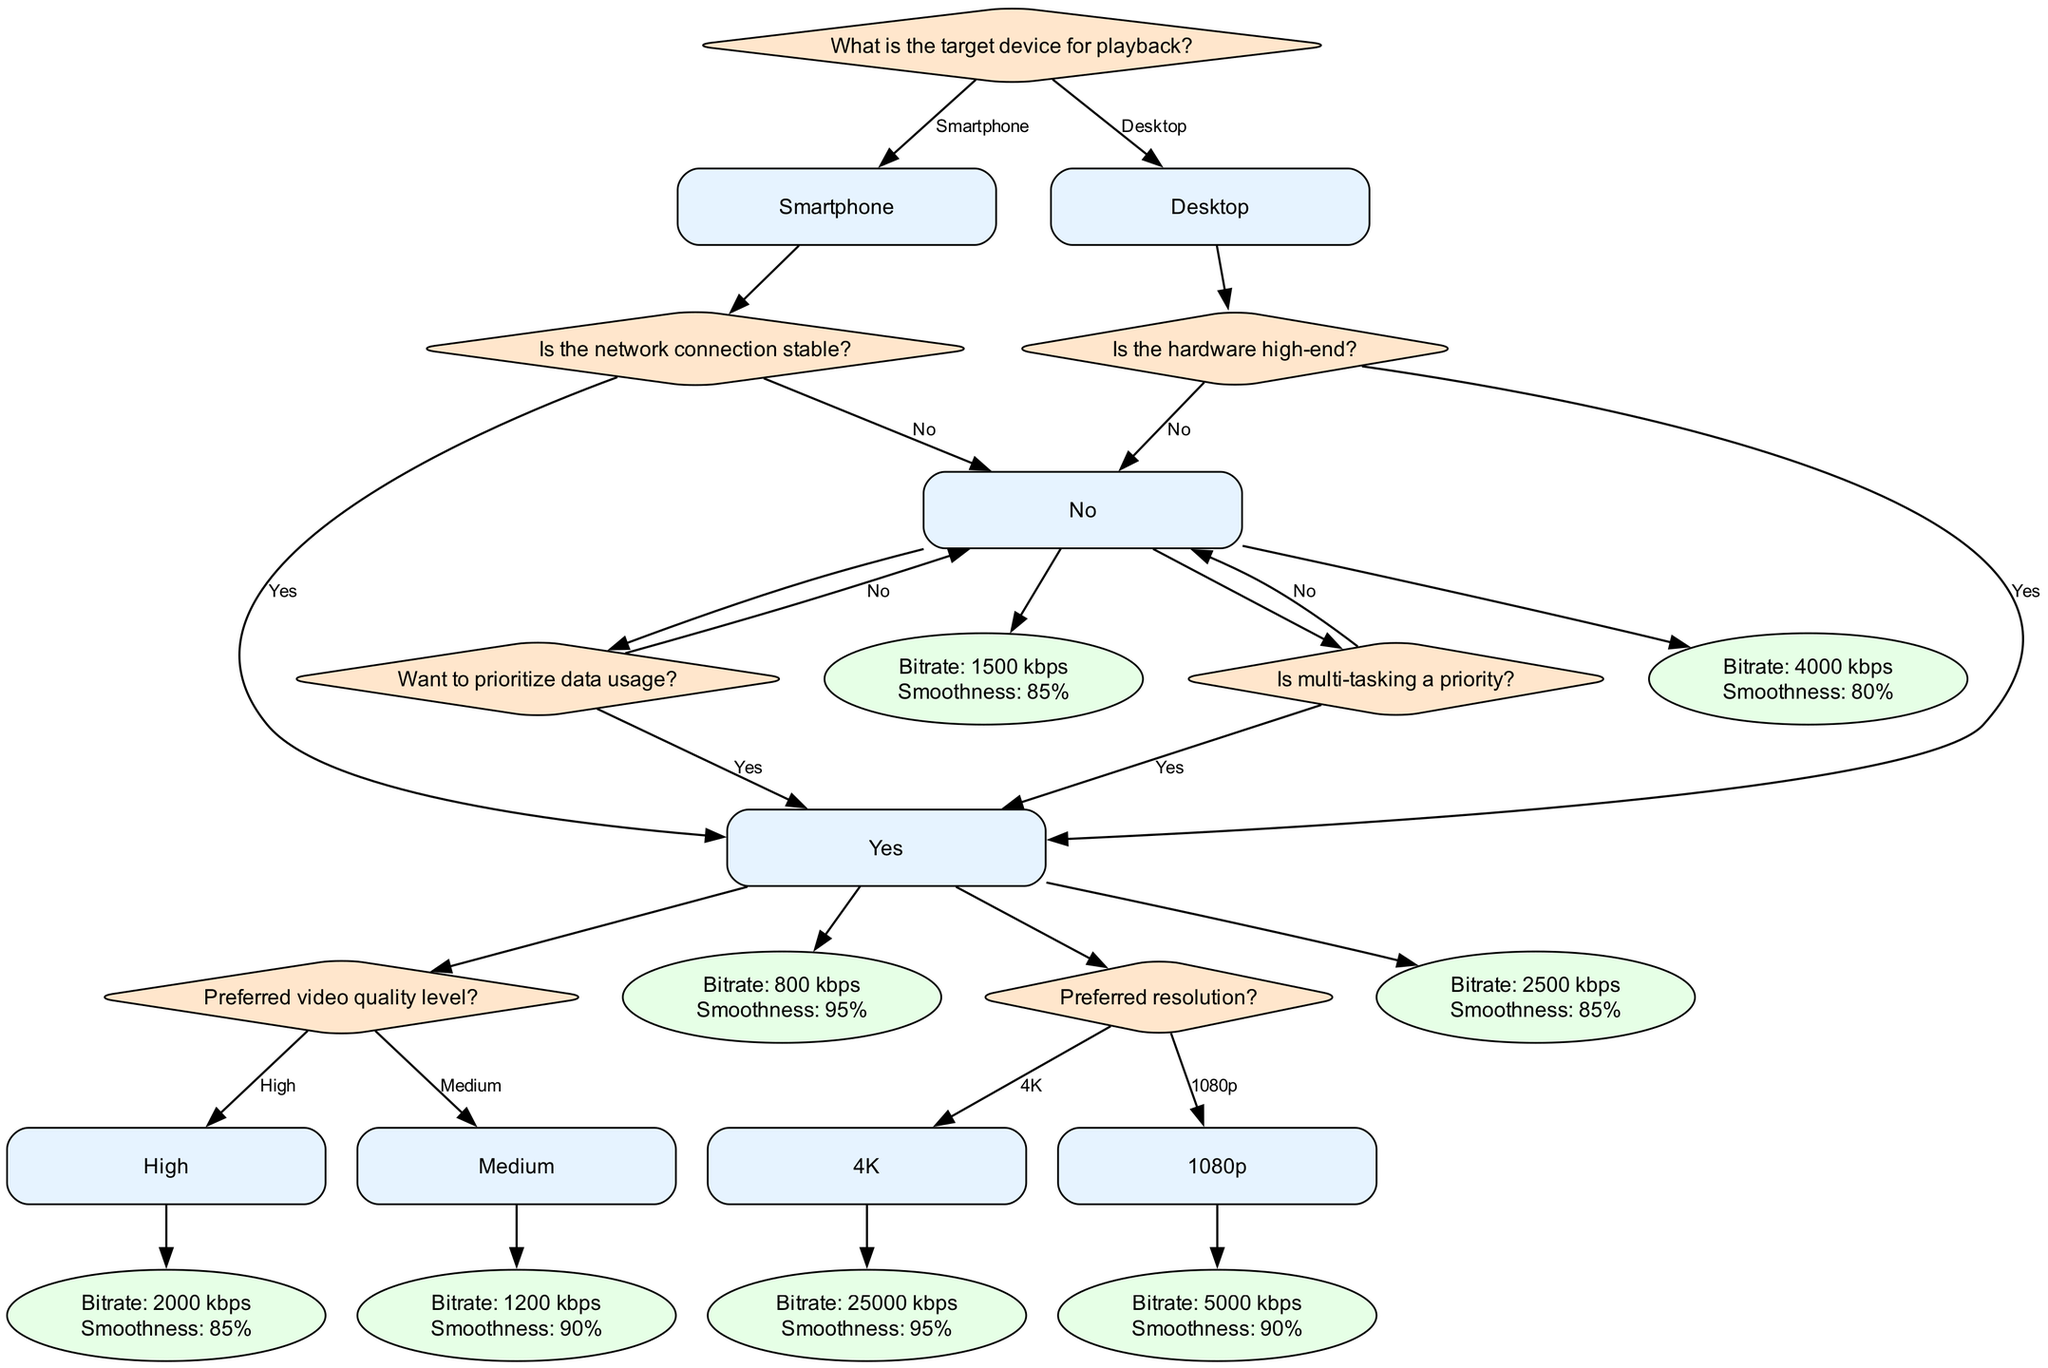What is the first question in the decision tree? The first question in the decision tree is "What is the target device for playback?" This is located at the root node and serves as the initial decision point for the tree.
Answer: What is the target device for playback? What happens if the target device is a smartphone and the network connection is not stable? If the target device is a smartphone and the network connection is not stable, the next question asked is "Want to prioritize data usage?" This leads to further options based on the user's preference for data consumption.
Answer: Want to prioritize data usage? What bitrate is recommended for high video quality on a smartphone with a stable network? For a smartphone with a stable network and a preference for high video quality, the recommended bitrate is 2000 kbps as specified in the action that follows.
Answer: 2000 kbps How does the choice of device affect playback smoothness? The choice of device affects playback smoothness through different pathways and settings. For example, a smartphone with medium video quality has a playback smoothness of 90%, while a desktop with high-end hardware and 4K resolution has 95% playback smoothness. Thus, device type and resolution significantly impact smoothness.
Answer: Device type and resolution What is the playback smoothness for a desktop with low-end hardware that does not prioritize multi-tasking? In this scenario, the playback smoothness for a desktop with low-end hardware and no prioritization on multi-tasking is 80%. This is determined by following the decision nodes for low-end hardware and the option of not prioritizing multi-tasking.
Answer: 80% 